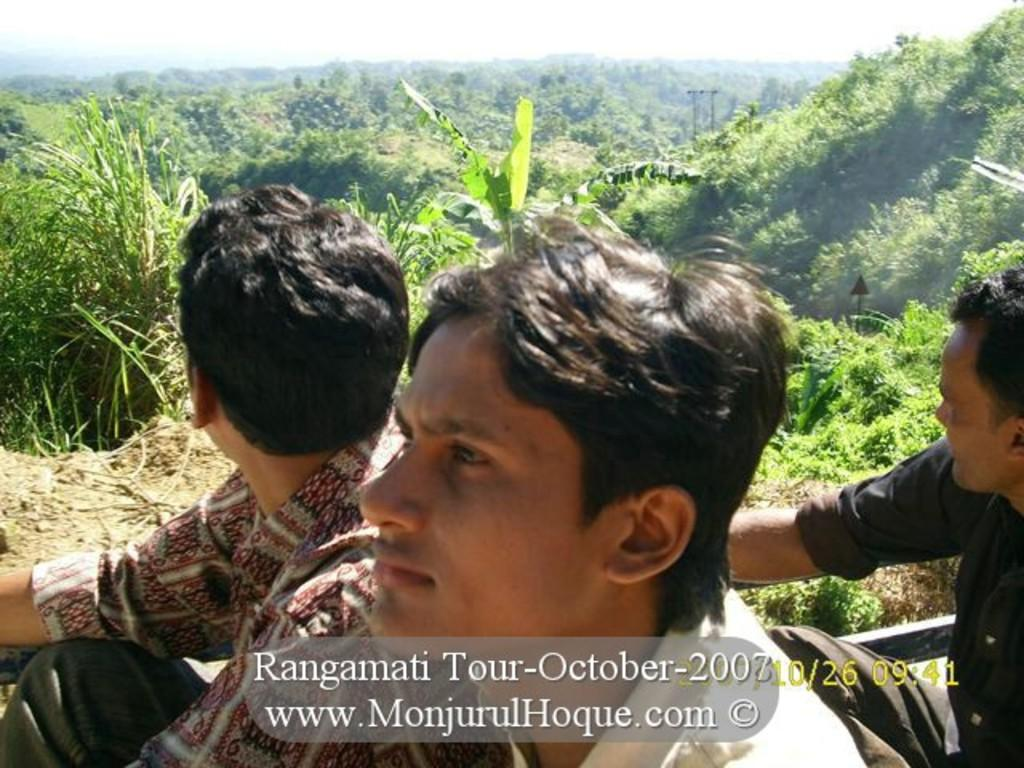Who or what can be seen in the image? There are people in the image. What type of natural elements are present in the image? There are trees and plants in the image. Is there any text or marking on the image? Yes, there is a watermark at the bottom of the image. What can be seen in the background of the image? The sky is visible in the background of the image. Are there any deer visible in the image? No, there are no deer present in the image. What type of cake is being served in the image? There is no cake present in the image. 